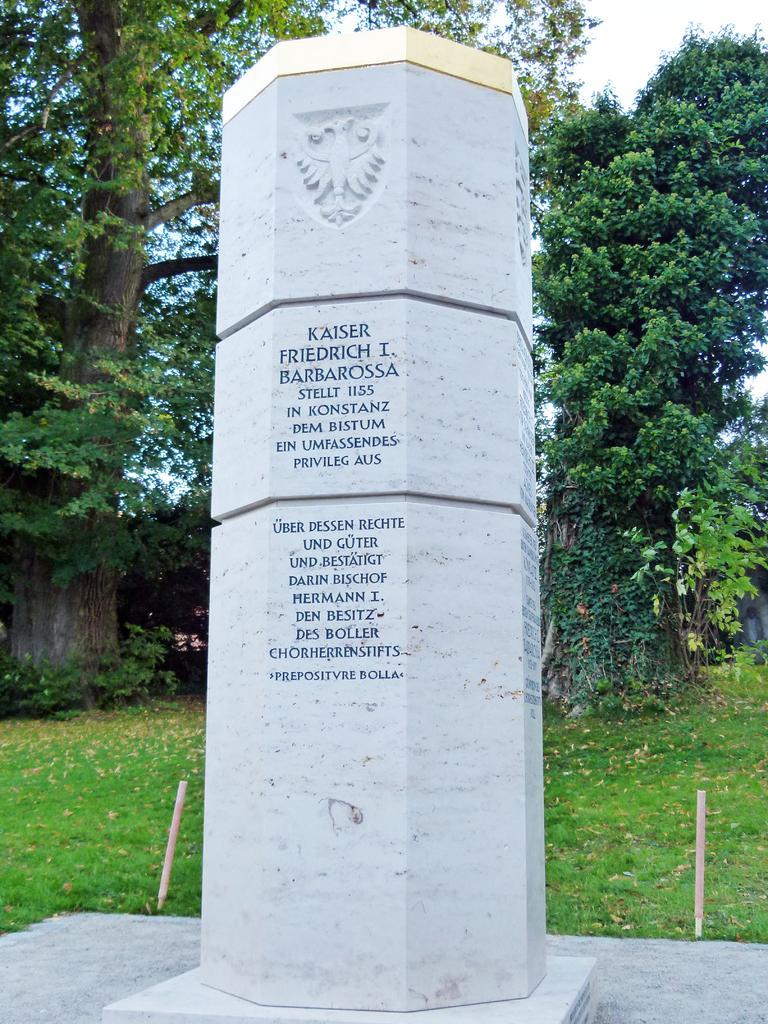Please provide a concise description of this image. This is the picture of a place where we have a pillar on which there is a sculptor and something written and behind there is some grass floor and some trees and plants. 